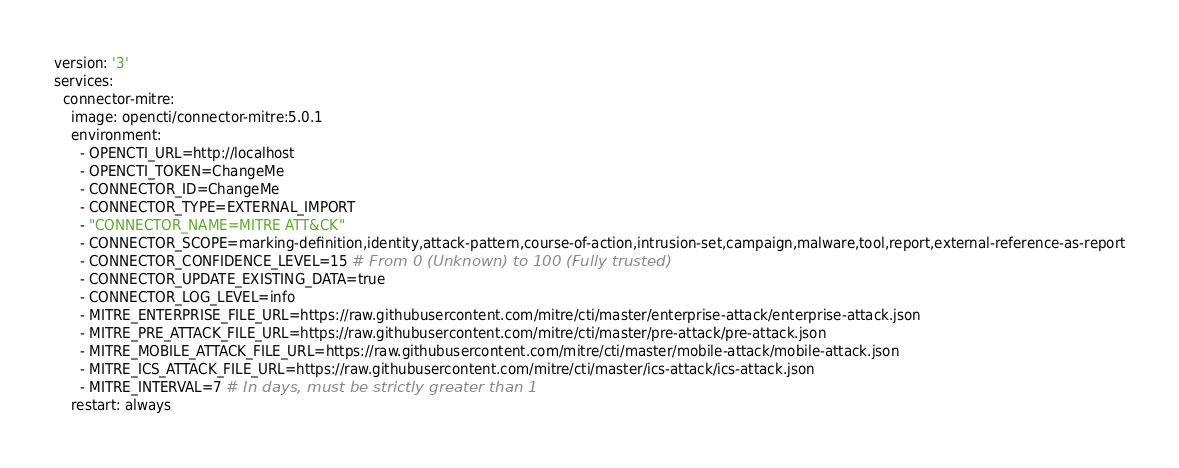Convert code to text. <code><loc_0><loc_0><loc_500><loc_500><_YAML_>version: '3'
services:
  connector-mitre:
    image: opencti/connector-mitre:5.0.1
    environment:
      - OPENCTI_URL=http://localhost
      - OPENCTI_TOKEN=ChangeMe
      - CONNECTOR_ID=ChangeMe
      - CONNECTOR_TYPE=EXTERNAL_IMPORT
      - "CONNECTOR_NAME=MITRE ATT&CK"
      - CONNECTOR_SCOPE=marking-definition,identity,attack-pattern,course-of-action,intrusion-set,campaign,malware,tool,report,external-reference-as-report
      - CONNECTOR_CONFIDENCE_LEVEL=15 # From 0 (Unknown) to 100 (Fully trusted)
      - CONNECTOR_UPDATE_EXISTING_DATA=true
      - CONNECTOR_LOG_LEVEL=info
      - MITRE_ENTERPRISE_FILE_URL=https://raw.githubusercontent.com/mitre/cti/master/enterprise-attack/enterprise-attack.json
      - MITRE_PRE_ATTACK_FILE_URL=https://raw.githubusercontent.com/mitre/cti/master/pre-attack/pre-attack.json
      - MITRE_MOBILE_ATTACK_FILE_URL=https://raw.githubusercontent.com/mitre/cti/master/mobile-attack/mobile-attack.json
      - MITRE_ICS_ATTACK_FILE_URL=https://raw.githubusercontent.com/mitre/cti/master/ics-attack/ics-attack.json
      - MITRE_INTERVAL=7 # In days, must be strictly greater than 1
    restart: always
</code> 